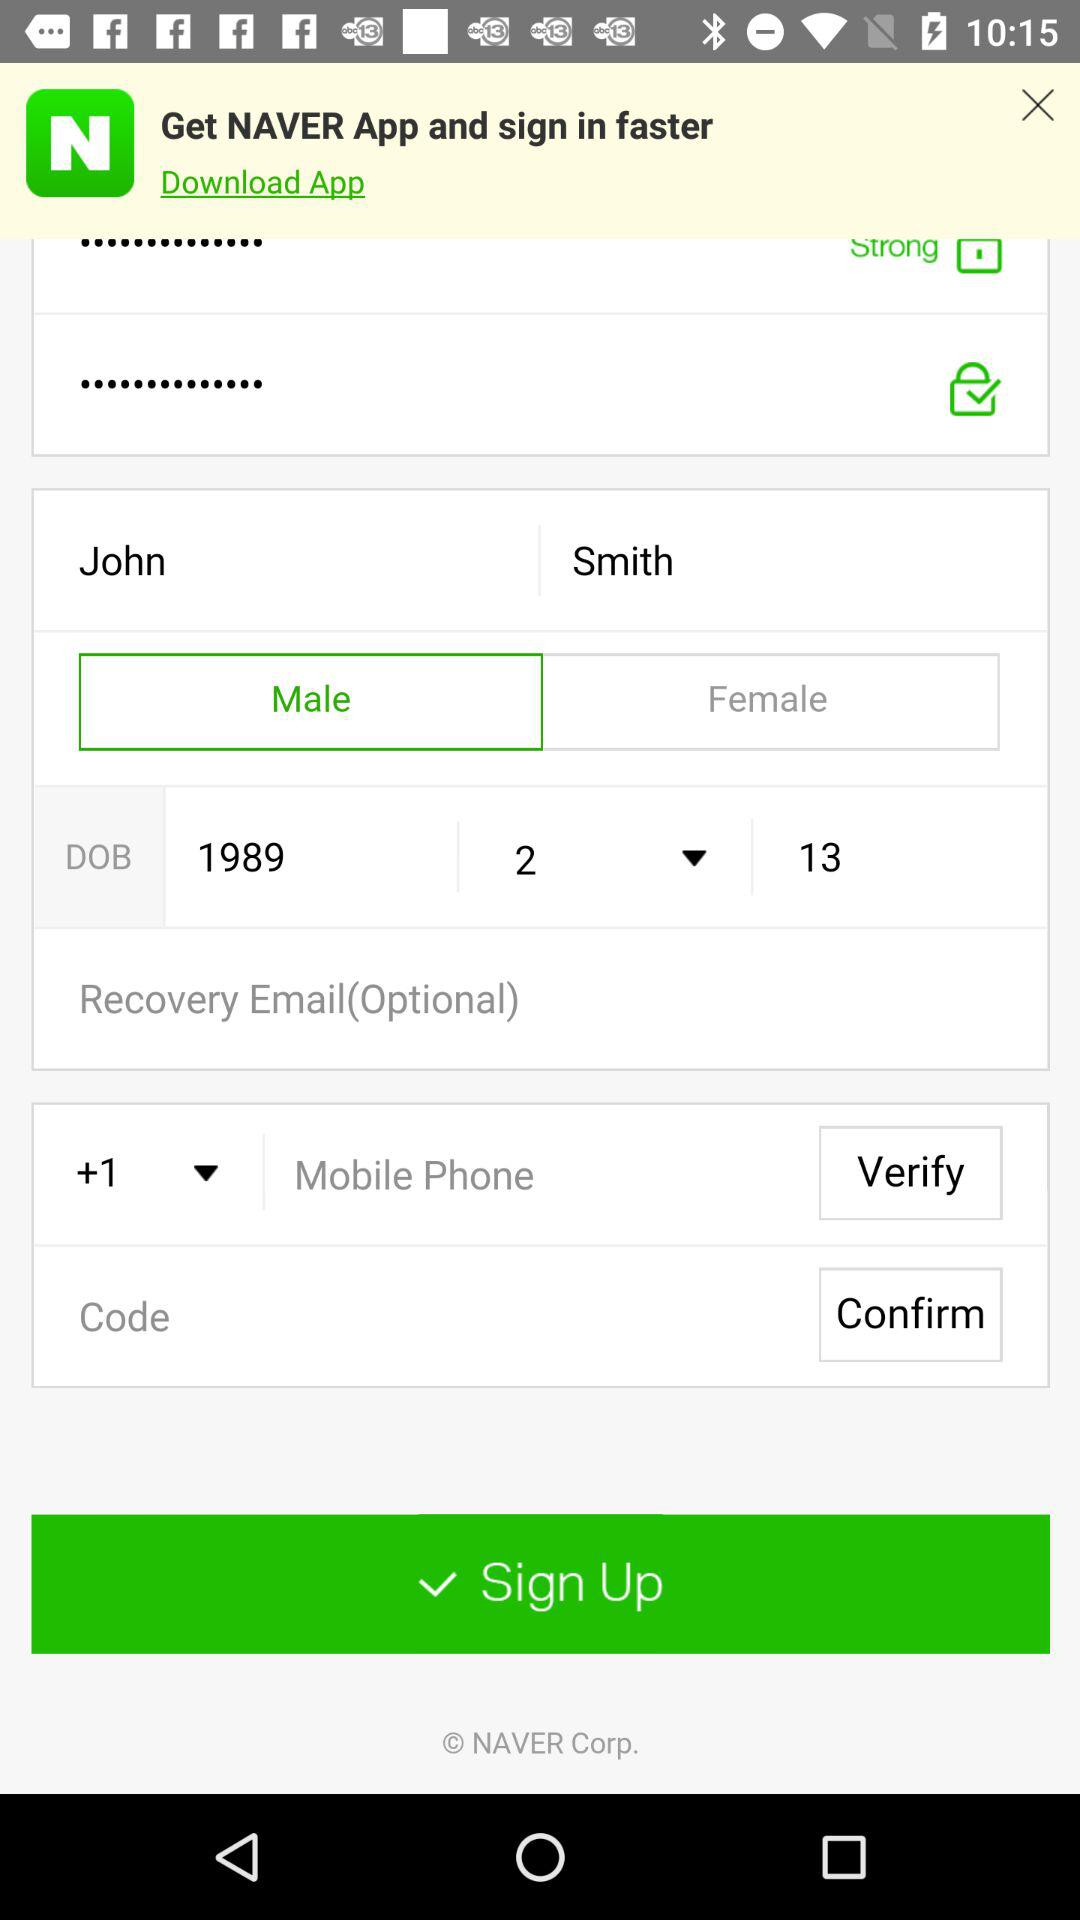What is the DOB of John Smith? The DOB of John Smith is February 13, 1989. 